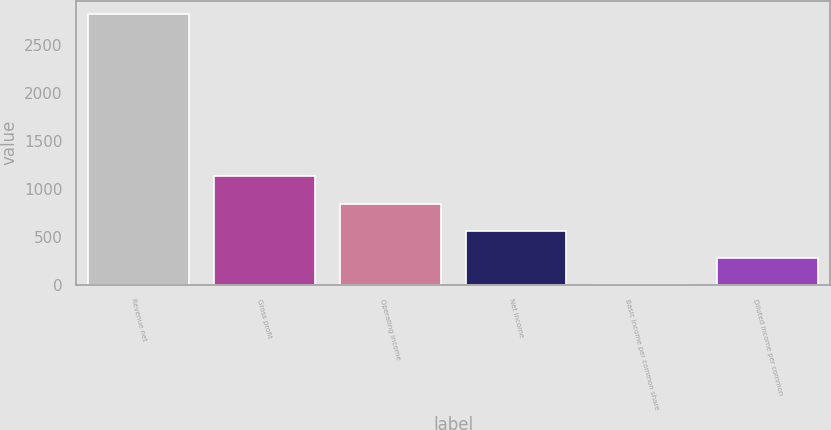<chart> <loc_0><loc_0><loc_500><loc_500><bar_chart><fcel>Revenue net<fcel>Gross profit<fcel>Operating income<fcel>Net income<fcel>Basic income per common share<fcel>Diluted income per common<nl><fcel>2822<fcel>1129<fcel>846.83<fcel>564.66<fcel>0.32<fcel>282.49<nl></chart> 